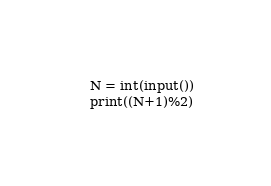<code> <loc_0><loc_0><loc_500><loc_500><_Python_>N = int(input())
print((N+1)%2)</code> 